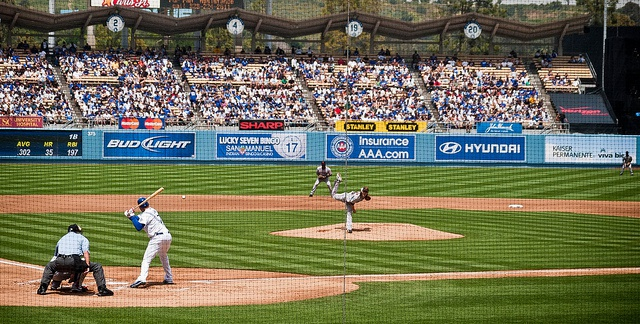Describe the objects in this image and their specific colors. I can see people in black, lightgray, gray, and darkgray tones, people in black, lavender, gray, and darkgreen tones, people in black, white, darkgray, and gray tones, people in black, lightgray, gray, and darkgray tones, and people in black, maroon, and gray tones in this image. 